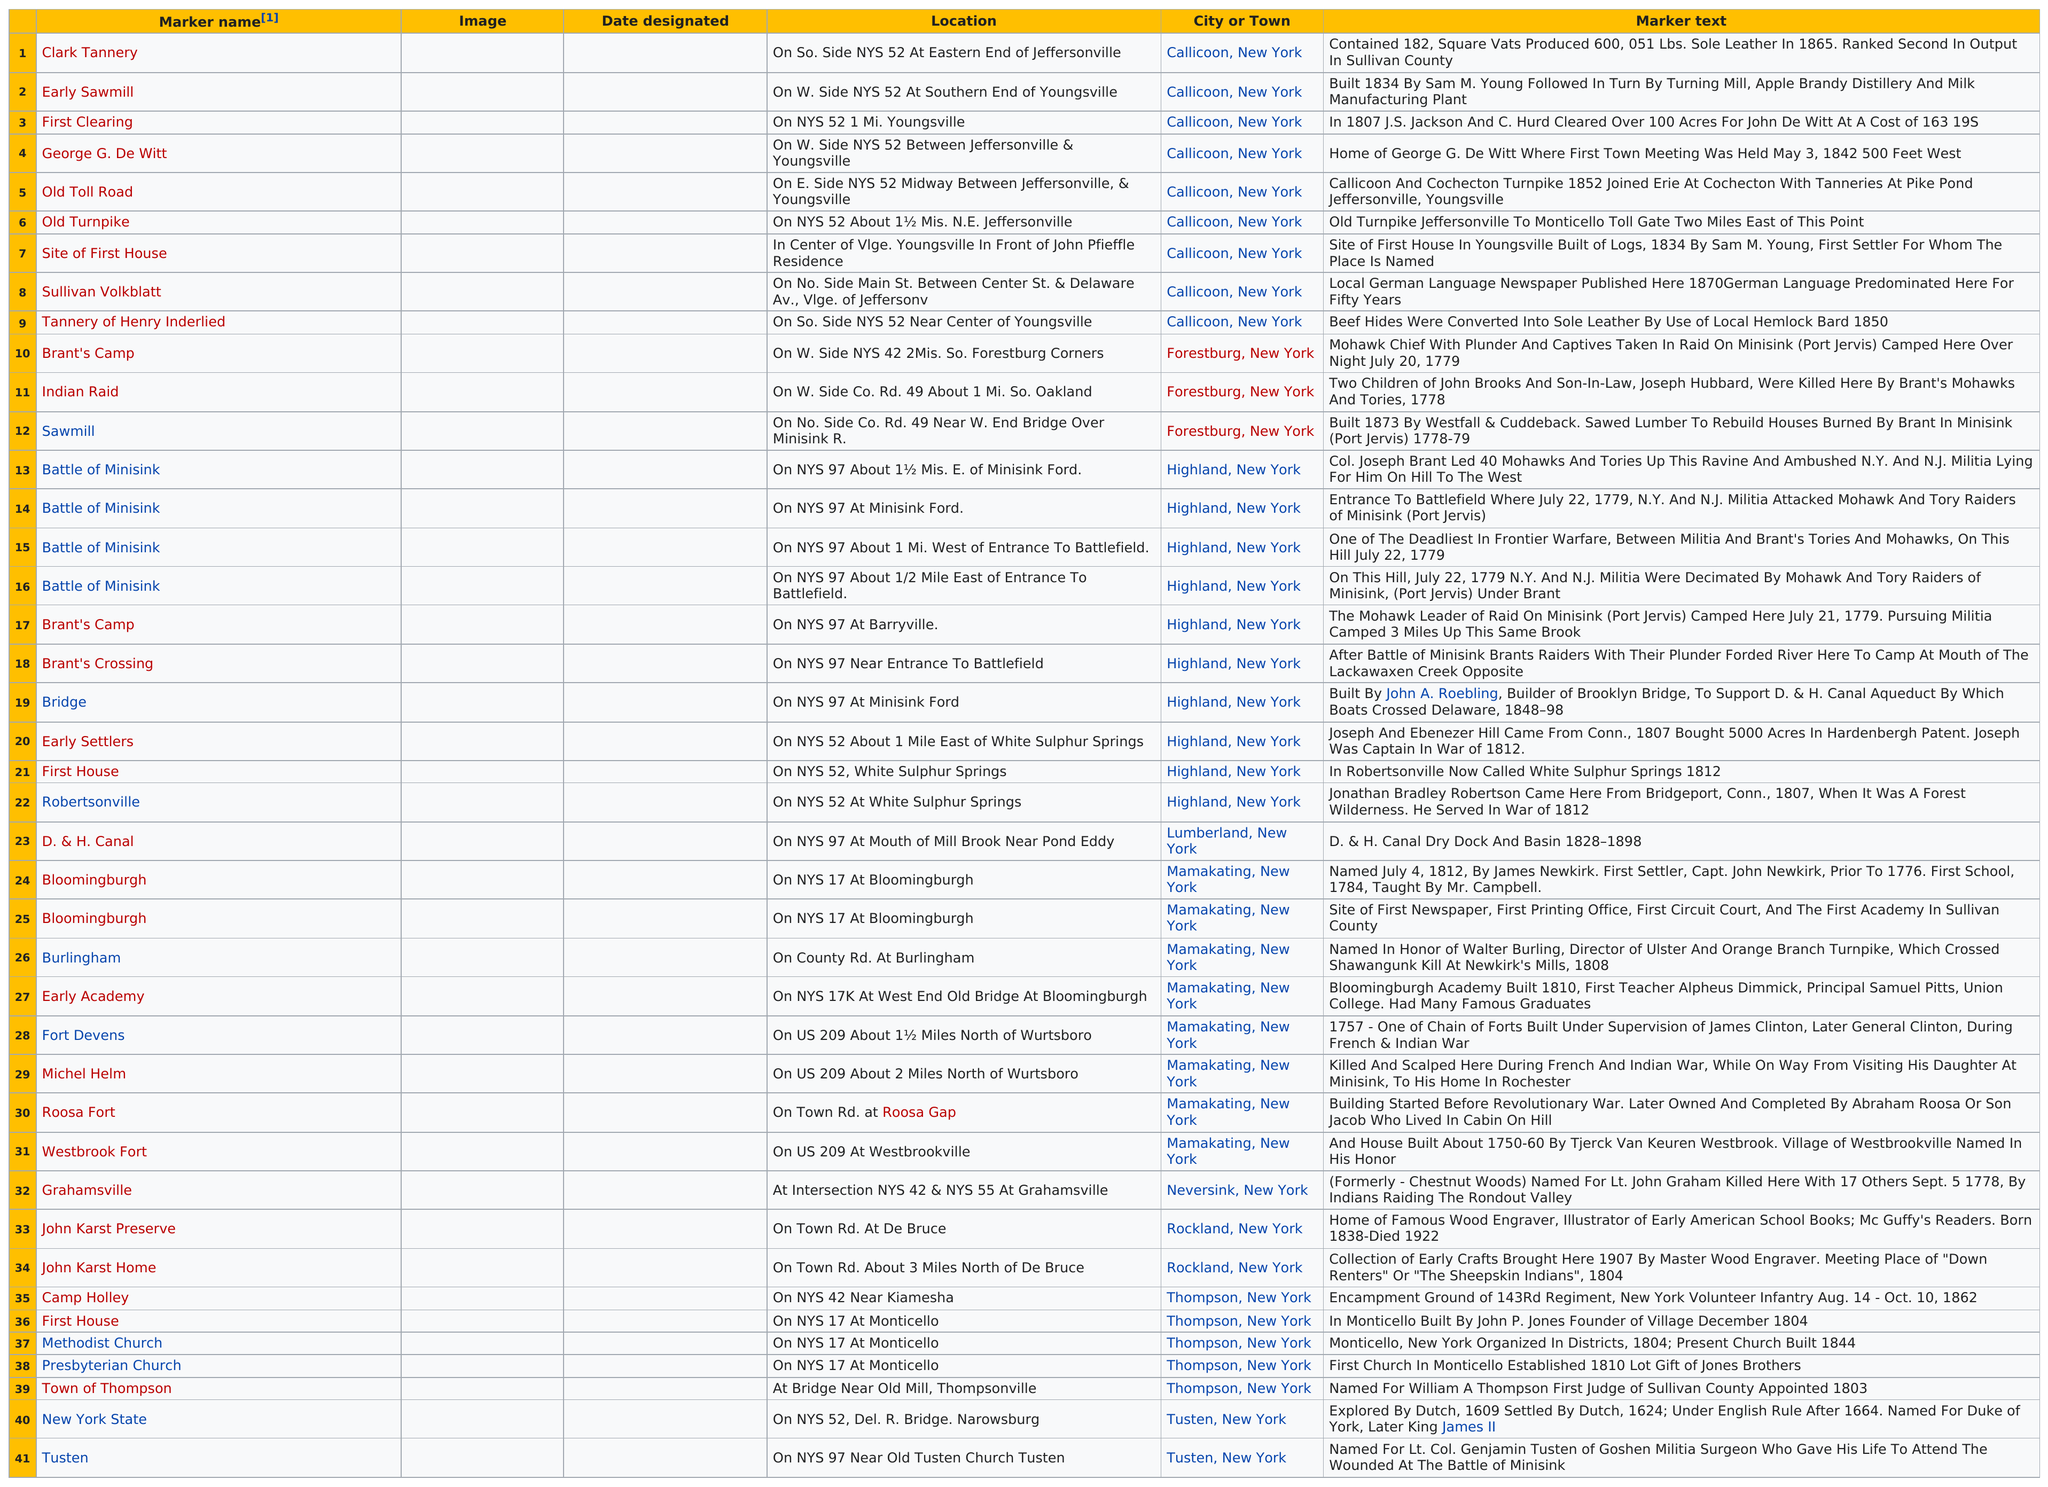Outline some significant characteristics in this image. Yes, locations and cities/towns are provided on the list. The marker after Clark Tannery is Early Sawmill. There are 10 markers listed in Highkand, New York. The number of churches listed is 1.. The total number of markers that start with the letter 'b' is 11. 